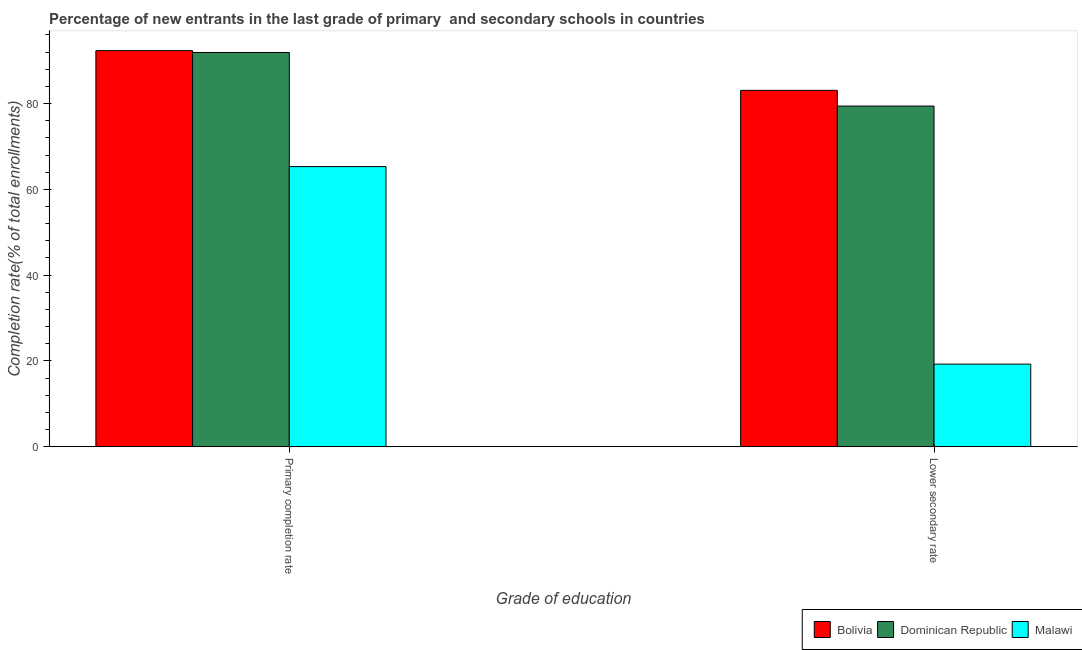How many groups of bars are there?
Offer a very short reply. 2. Are the number of bars per tick equal to the number of legend labels?
Provide a short and direct response. Yes. Are the number of bars on each tick of the X-axis equal?
Provide a succinct answer. Yes. What is the label of the 2nd group of bars from the left?
Your response must be concise. Lower secondary rate. What is the completion rate in secondary schools in Malawi?
Ensure brevity in your answer.  19.26. Across all countries, what is the maximum completion rate in secondary schools?
Give a very brief answer. 83.09. Across all countries, what is the minimum completion rate in secondary schools?
Your answer should be very brief. 19.26. In which country was the completion rate in primary schools maximum?
Offer a terse response. Bolivia. In which country was the completion rate in secondary schools minimum?
Offer a terse response. Malawi. What is the total completion rate in primary schools in the graph?
Offer a very short reply. 249.57. What is the difference between the completion rate in primary schools in Bolivia and that in Dominican Republic?
Offer a terse response. 0.43. What is the difference between the completion rate in secondary schools in Bolivia and the completion rate in primary schools in Malawi?
Give a very brief answer. 17.78. What is the average completion rate in primary schools per country?
Your answer should be compact. 83.19. What is the difference between the completion rate in secondary schools and completion rate in primary schools in Dominican Republic?
Offer a very short reply. -12.49. In how many countries, is the completion rate in primary schools greater than 88 %?
Provide a succinct answer. 2. What is the ratio of the completion rate in secondary schools in Malawi to that in Bolivia?
Offer a terse response. 0.23. Is the completion rate in primary schools in Dominican Republic less than that in Bolivia?
Provide a succinct answer. Yes. What does the 3rd bar from the left in Primary completion rate represents?
Make the answer very short. Malawi. What does the 1st bar from the right in Lower secondary rate represents?
Your answer should be very brief. Malawi. How many bars are there?
Your answer should be very brief. 6. Are all the bars in the graph horizontal?
Give a very brief answer. No. What is the difference between two consecutive major ticks on the Y-axis?
Make the answer very short. 20. Are the values on the major ticks of Y-axis written in scientific E-notation?
Your answer should be compact. No. Does the graph contain any zero values?
Your answer should be compact. No. Does the graph contain grids?
Your response must be concise. No. Where does the legend appear in the graph?
Your answer should be very brief. Bottom right. How are the legend labels stacked?
Give a very brief answer. Horizontal. What is the title of the graph?
Provide a succinct answer. Percentage of new entrants in the last grade of primary  and secondary schools in countries. Does "Bolivia" appear as one of the legend labels in the graph?
Your answer should be very brief. Yes. What is the label or title of the X-axis?
Ensure brevity in your answer.  Grade of education. What is the label or title of the Y-axis?
Offer a very short reply. Completion rate(% of total enrollments). What is the Completion rate(% of total enrollments) of Bolivia in Primary completion rate?
Make the answer very short. 92.35. What is the Completion rate(% of total enrollments) of Dominican Republic in Primary completion rate?
Provide a succinct answer. 91.91. What is the Completion rate(% of total enrollments) of Malawi in Primary completion rate?
Provide a short and direct response. 65.31. What is the Completion rate(% of total enrollments) of Bolivia in Lower secondary rate?
Provide a succinct answer. 83.09. What is the Completion rate(% of total enrollments) of Dominican Republic in Lower secondary rate?
Your answer should be compact. 79.42. What is the Completion rate(% of total enrollments) of Malawi in Lower secondary rate?
Provide a succinct answer. 19.26. Across all Grade of education, what is the maximum Completion rate(% of total enrollments) in Bolivia?
Ensure brevity in your answer.  92.35. Across all Grade of education, what is the maximum Completion rate(% of total enrollments) of Dominican Republic?
Offer a very short reply. 91.91. Across all Grade of education, what is the maximum Completion rate(% of total enrollments) in Malawi?
Your answer should be compact. 65.31. Across all Grade of education, what is the minimum Completion rate(% of total enrollments) in Bolivia?
Offer a terse response. 83.09. Across all Grade of education, what is the minimum Completion rate(% of total enrollments) of Dominican Republic?
Your answer should be compact. 79.42. Across all Grade of education, what is the minimum Completion rate(% of total enrollments) in Malawi?
Keep it short and to the point. 19.26. What is the total Completion rate(% of total enrollments) in Bolivia in the graph?
Keep it short and to the point. 175.43. What is the total Completion rate(% of total enrollments) of Dominican Republic in the graph?
Give a very brief answer. 171.34. What is the total Completion rate(% of total enrollments) of Malawi in the graph?
Offer a very short reply. 84.57. What is the difference between the Completion rate(% of total enrollments) of Bolivia in Primary completion rate and that in Lower secondary rate?
Provide a short and direct response. 9.26. What is the difference between the Completion rate(% of total enrollments) in Dominican Republic in Primary completion rate and that in Lower secondary rate?
Give a very brief answer. 12.49. What is the difference between the Completion rate(% of total enrollments) of Malawi in Primary completion rate and that in Lower secondary rate?
Provide a succinct answer. 46.05. What is the difference between the Completion rate(% of total enrollments) of Bolivia in Primary completion rate and the Completion rate(% of total enrollments) of Dominican Republic in Lower secondary rate?
Keep it short and to the point. 12.92. What is the difference between the Completion rate(% of total enrollments) in Bolivia in Primary completion rate and the Completion rate(% of total enrollments) in Malawi in Lower secondary rate?
Offer a very short reply. 73.08. What is the difference between the Completion rate(% of total enrollments) in Dominican Republic in Primary completion rate and the Completion rate(% of total enrollments) in Malawi in Lower secondary rate?
Offer a terse response. 72.65. What is the average Completion rate(% of total enrollments) of Bolivia per Grade of education?
Your answer should be compact. 87.72. What is the average Completion rate(% of total enrollments) of Dominican Republic per Grade of education?
Make the answer very short. 85.67. What is the average Completion rate(% of total enrollments) of Malawi per Grade of education?
Your response must be concise. 42.28. What is the difference between the Completion rate(% of total enrollments) of Bolivia and Completion rate(% of total enrollments) of Dominican Republic in Primary completion rate?
Keep it short and to the point. 0.43. What is the difference between the Completion rate(% of total enrollments) in Bolivia and Completion rate(% of total enrollments) in Malawi in Primary completion rate?
Give a very brief answer. 27.04. What is the difference between the Completion rate(% of total enrollments) in Dominican Republic and Completion rate(% of total enrollments) in Malawi in Primary completion rate?
Ensure brevity in your answer.  26.61. What is the difference between the Completion rate(% of total enrollments) in Bolivia and Completion rate(% of total enrollments) in Dominican Republic in Lower secondary rate?
Give a very brief answer. 3.67. What is the difference between the Completion rate(% of total enrollments) of Bolivia and Completion rate(% of total enrollments) of Malawi in Lower secondary rate?
Your response must be concise. 63.83. What is the difference between the Completion rate(% of total enrollments) of Dominican Republic and Completion rate(% of total enrollments) of Malawi in Lower secondary rate?
Offer a very short reply. 60.16. What is the ratio of the Completion rate(% of total enrollments) in Bolivia in Primary completion rate to that in Lower secondary rate?
Offer a terse response. 1.11. What is the ratio of the Completion rate(% of total enrollments) in Dominican Republic in Primary completion rate to that in Lower secondary rate?
Offer a very short reply. 1.16. What is the ratio of the Completion rate(% of total enrollments) in Malawi in Primary completion rate to that in Lower secondary rate?
Provide a succinct answer. 3.39. What is the difference between the highest and the second highest Completion rate(% of total enrollments) in Bolivia?
Your response must be concise. 9.26. What is the difference between the highest and the second highest Completion rate(% of total enrollments) of Dominican Republic?
Your answer should be compact. 12.49. What is the difference between the highest and the second highest Completion rate(% of total enrollments) in Malawi?
Ensure brevity in your answer.  46.05. What is the difference between the highest and the lowest Completion rate(% of total enrollments) of Bolivia?
Offer a terse response. 9.26. What is the difference between the highest and the lowest Completion rate(% of total enrollments) in Dominican Republic?
Make the answer very short. 12.49. What is the difference between the highest and the lowest Completion rate(% of total enrollments) in Malawi?
Give a very brief answer. 46.05. 